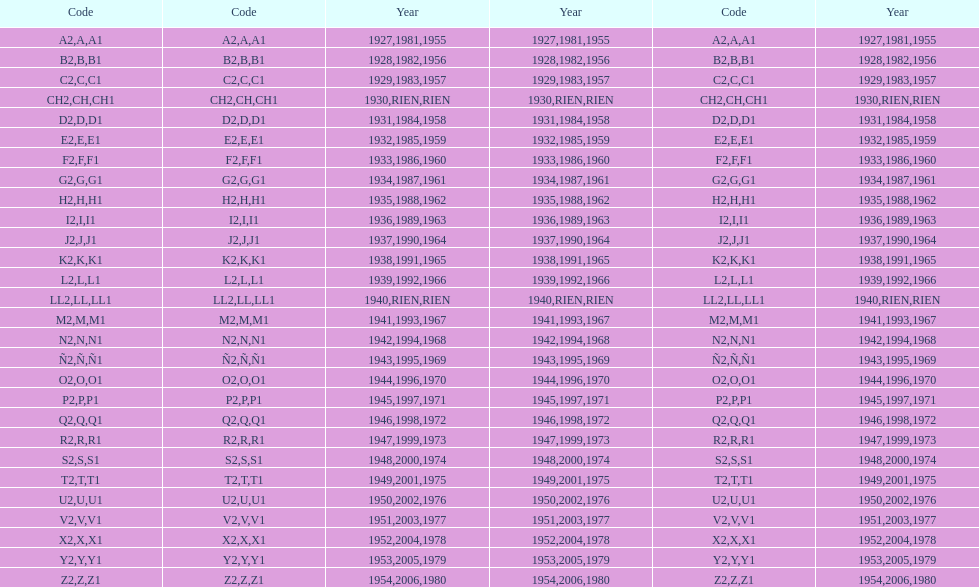Write the full table. {'header': ['Code', 'Code', 'Year', 'Year', 'Code', 'Year'], 'rows': [['A2', 'A', '1927', '1981', 'A1', '1955'], ['B2', 'B', '1928', '1982', 'B1', '1956'], ['C2', 'C', '1929', '1983', 'C1', '1957'], ['CH2', 'CH', '1930', 'RIEN', 'CH1', 'RIEN'], ['D2', 'D', '1931', '1984', 'D1', '1958'], ['E2', 'E', '1932', '1985', 'E1', '1959'], ['F2', 'F', '1933', '1986', 'F1', '1960'], ['G2', 'G', '1934', '1987', 'G1', '1961'], ['H2', 'H', '1935', '1988', 'H1', '1962'], ['I2', 'I', '1936', '1989', 'I1', '1963'], ['J2', 'J', '1937', '1990', 'J1', '1964'], ['K2', 'K', '1938', '1991', 'K1', '1965'], ['L2', 'L', '1939', '1992', 'L1', '1966'], ['LL2', 'LL', '1940', 'RIEN', 'LL1', 'RIEN'], ['M2', 'M', '1941', '1993', 'M1', '1967'], ['N2', 'N', '1942', '1994', 'N1', '1968'], ['Ñ2', 'Ñ', '1943', '1995', 'Ñ1', '1969'], ['O2', 'O', '1944', '1996', 'O1', '1970'], ['P2', 'P', '1945', '1997', 'P1', '1971'], ['Q2', 'Q', '1946', '1998', 'Q1', '1972'], ['R2', 'R', '1947', '1999', 'R1', '1973'], ['S2', 'S', '1948', '2000', 'S1', '1974'], ['T2', 'T', '1949', '2001', 'T1', '1975'], ['U2', 'U', '1950', '2002', 'U1', '1976'], ['V2', 'V', '1951', '2003', 'V1', '1977'], ['X2', 'X', '1952', '2004', 'X1', '1978'], ['Y2', 'Y', '1953', '2005', 'Y1', '1979'], ['Z2', 'Z', '1954', '2006', 'Z1', '1980']]} What was the lowest year stamped? 1927. 